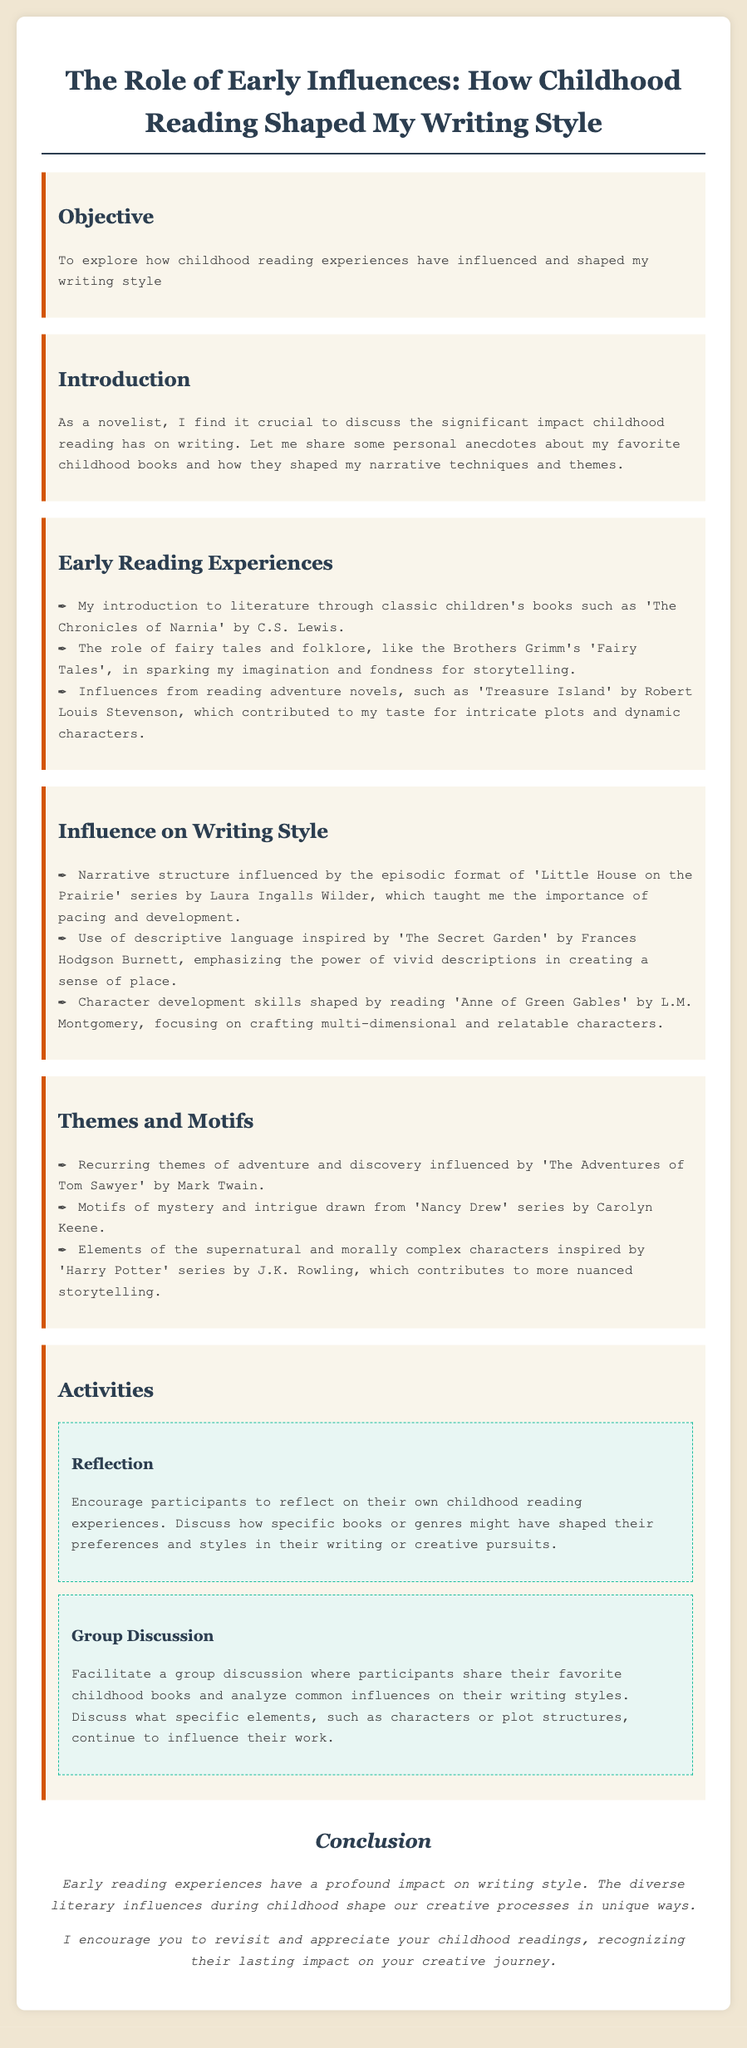What is the objective of the lesson plan? The objective is to explore how childhood reading experiences have influenced and shaped writing style.
Answer: To explore how childhood reading experiences have influenced and shaped my writing style Who wrote 'The Chronicles of Narnia'? The document mentions C.S. Lewis as the author of 'The Chronicles of Narnia'.
Answer: C.S. Lewis Which book series influenced the narrative structure mentioned in the document? The document states that 'Little House on the Prairie' series influenced narrative structure.
Answer: 'Little House on the Prairie' Name one theme influenced by 'The Adventures of Tom Sawyer'. The document specifies adventure and discovery as a recurring theme influenced by 'The Adventures of Tom Sawyer'.
Answer: Adventure and discovery What type of activity is suggested for participants to reflect on their reading experiences? The document suggests a reflection activity for participants to discuss their own childhood reading experiences.
Answer: Reflection What genre is associated with the influence of the 'Nancy Drew' series? Mystery and intrigue are the motifs drawn from the 'Nancy Drew' series.
Answer: Mystery and intrigue How should participants share their favorite childhood books? The group discussion allows participants to share their favorite childhood books and analyze common influences.
Answer: Group Discussion What is the concluding message of the lesson plan? The conclusion emphasizes the profound impact of early reading experiences on writing style.
Answer: Early reading experiences have a profound impact on writing style 